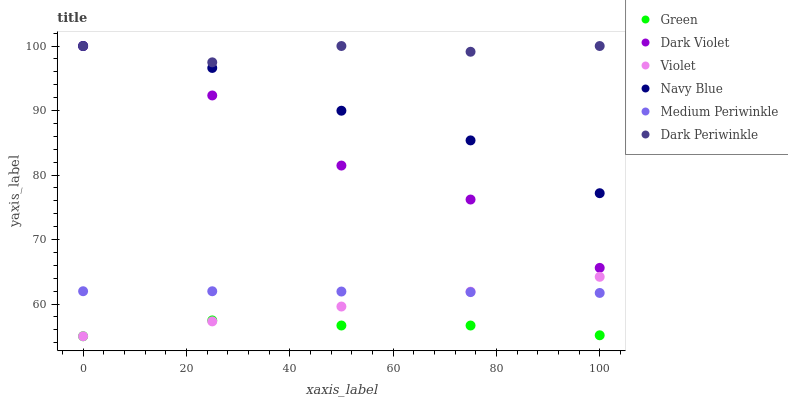Does Green have the minimum area under the curve?
Answer yes or no. Yes. Does Dark Periwinkle have the maximum area under the curve?
Answer yes or no. Yes. Does Medium Periwinkle have the minimum area under the curve?
Answer yes or no. No. Does Medium Periwinkle have the maximum area under the curve?
Answer yes or no. No. Is Violet the smoothest?
Answer yes or no. Yes. Is Dark Violet the roughest?
Answer yes or no. Yes. Is Medium Periwinkle the smoothest?
Answer yes or no. No. Is Medium Periwinkle the roughest?
Answer yes or no. No. Does Green have the lowest value?
Answer yes or no. Yes. Does Medium Periwinkle have the lowest value?
Answer yes or no. No. Does Dark Periwinkle have the highest value?
Answer yes or no. Yes. Does Medium Periwinkle have the highest value?
Answer yes or no. No. Is Green less than Dark Violet?
Answer yes or no. Yes. Is Dark Violet greater than Violet?
Answer yes or no. Yes. Does Dark Periwinkle intersect Dark Violet?
Answer yes or no. Yes. Is Dark Periwinkle less than Dark Violet?
Answer yes or no. No. Is Dark Periwinkle greater than Dark Violet?
Answer yes or no. No. Does Green intersect Dark Violet?
Answer yes or no. No. 